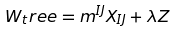<formula> <loc_0><loc_0><loc_500><loc_500>W _ { t } r e e = m ^ { I J } X _ { I J } + \lambda Z</formula> 